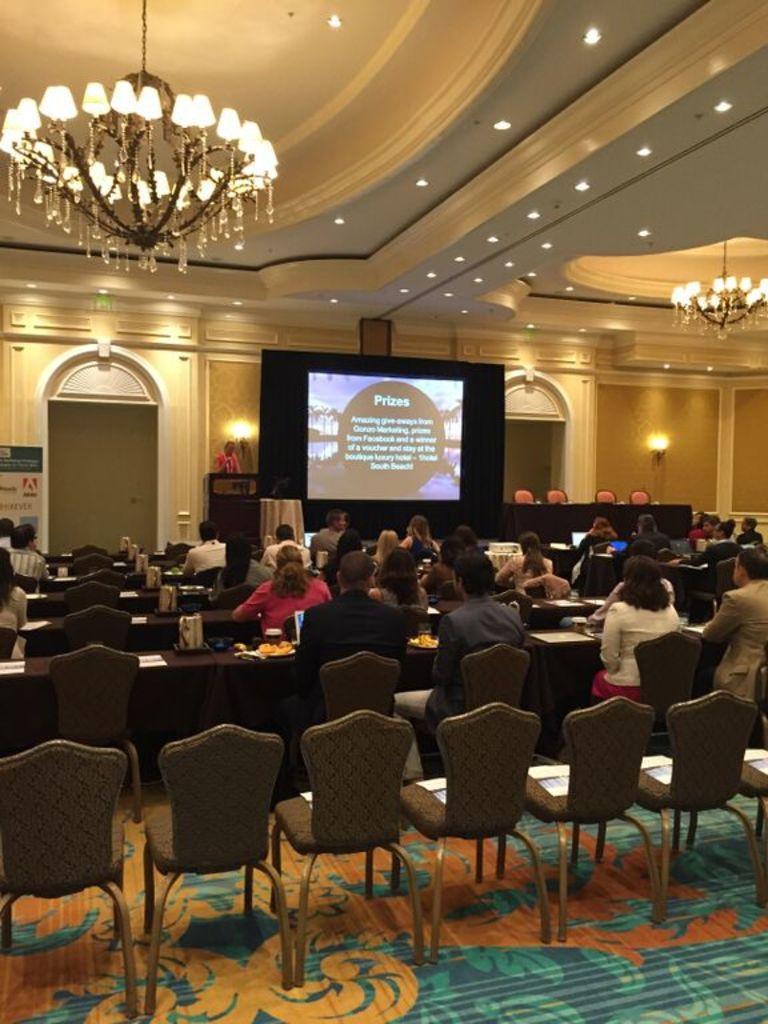In one or two sentences, can you explain what this image depicts? The image is clicked inside a hall. And there are many people sitting in the chairs. There is a screen in the middle. At the top there is light attached to the roof. And at the bottom there is floor mat in green color. 